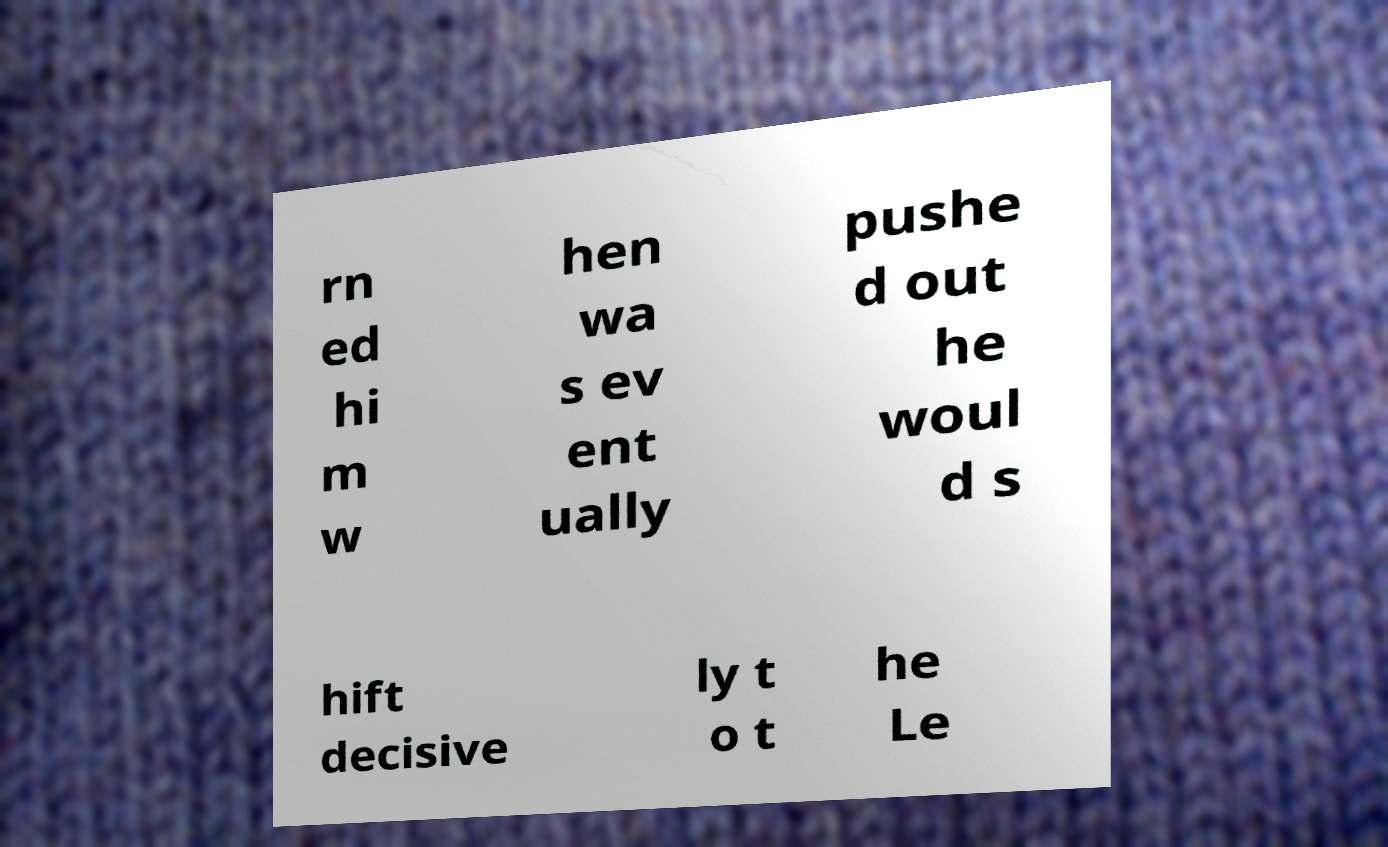I need the written content from this picture converted into text. Can you do that? rn ed hi m w hen wa s ev ent ually pushe d out he woul d s hift decisive ly t o t he Le 